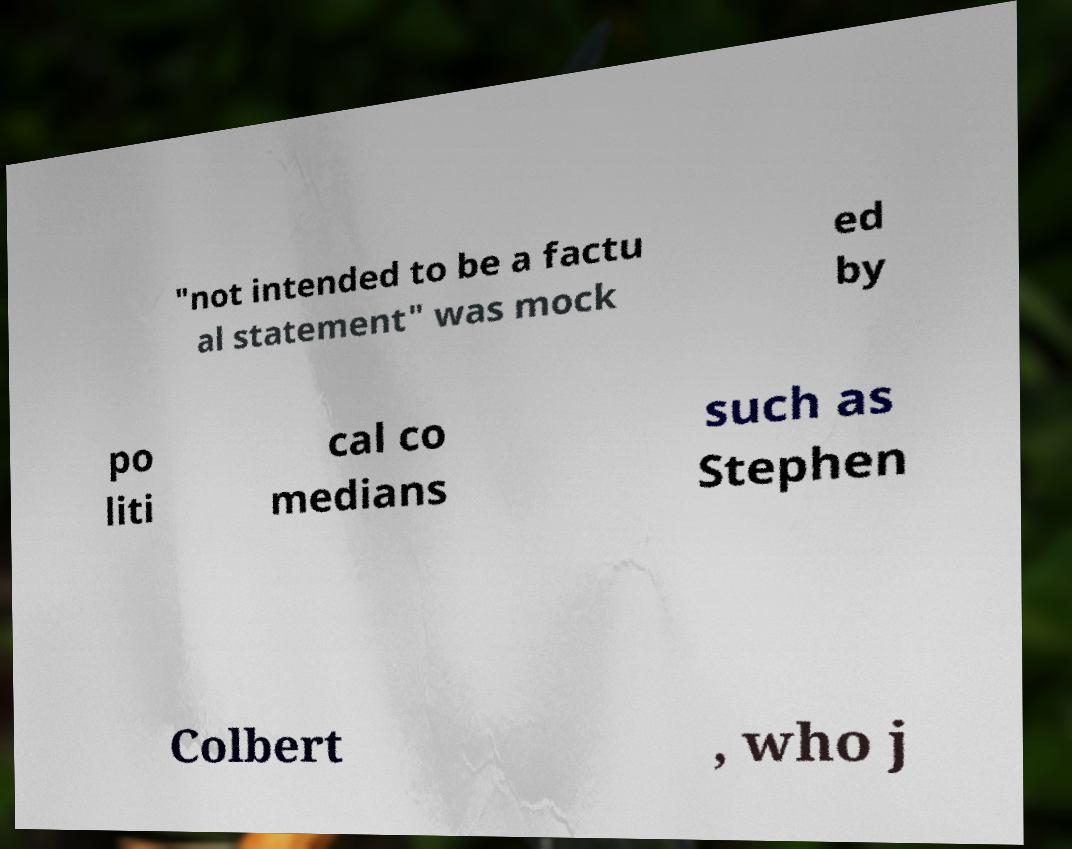Please read and relay the text visible in this image. What does it say? "not intended to be a factu al statement" was mock ed by po liti cal co medians such as Stephen Colbert , who j 